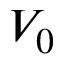<formula> <loc_0><loc_0><loc_500><loc_500>V _ { 0 }</formula> 